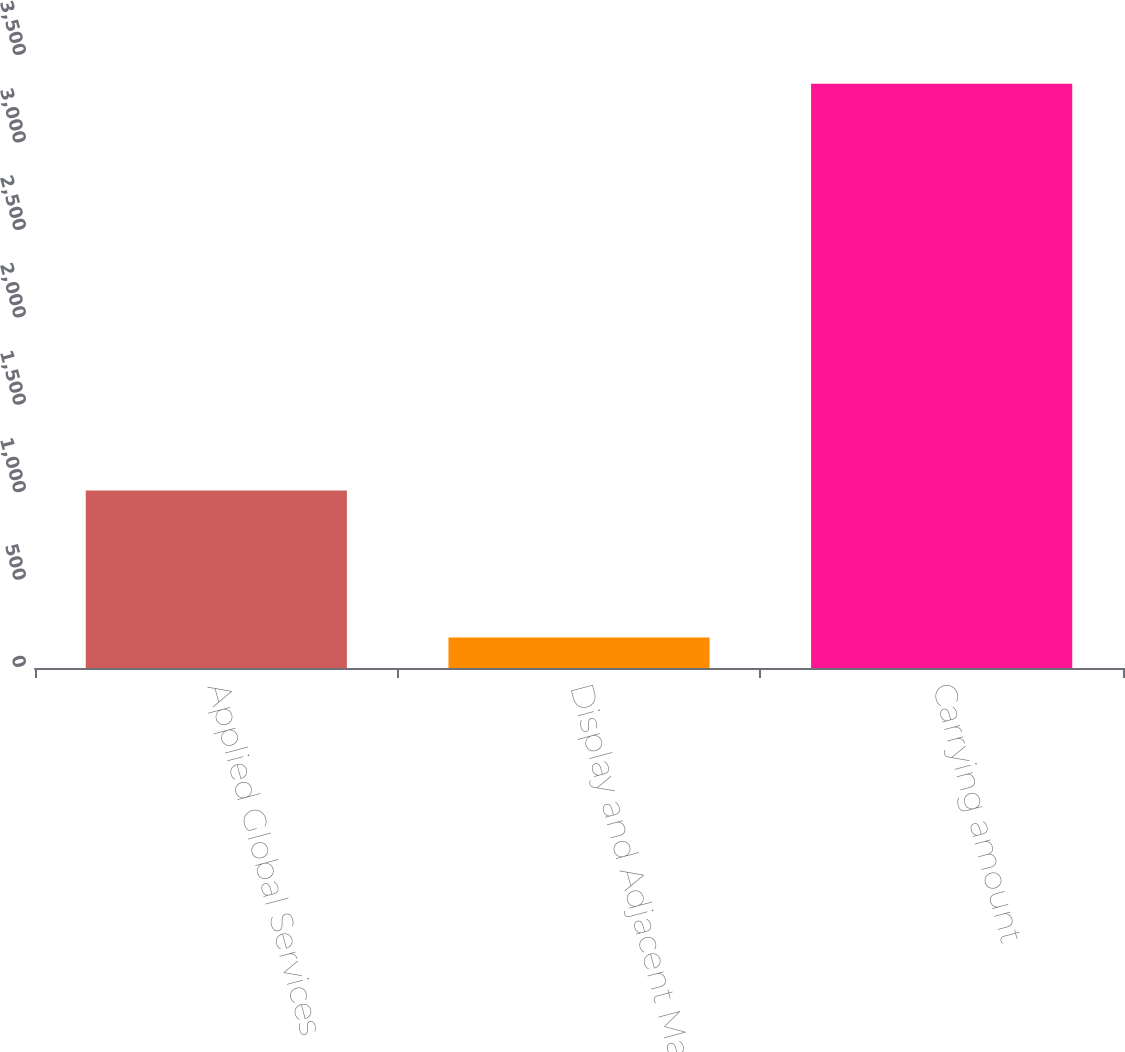Convert chart. <chart><loc_0><loc_0><loc_500><loc_500><bar_chart><fcel>Applied Global Services<fcel>Display and Adjacent Markets<fcel>Carrying amount<nl><fcel>1015<fcel>175<fcel>3341<nl></chart> 